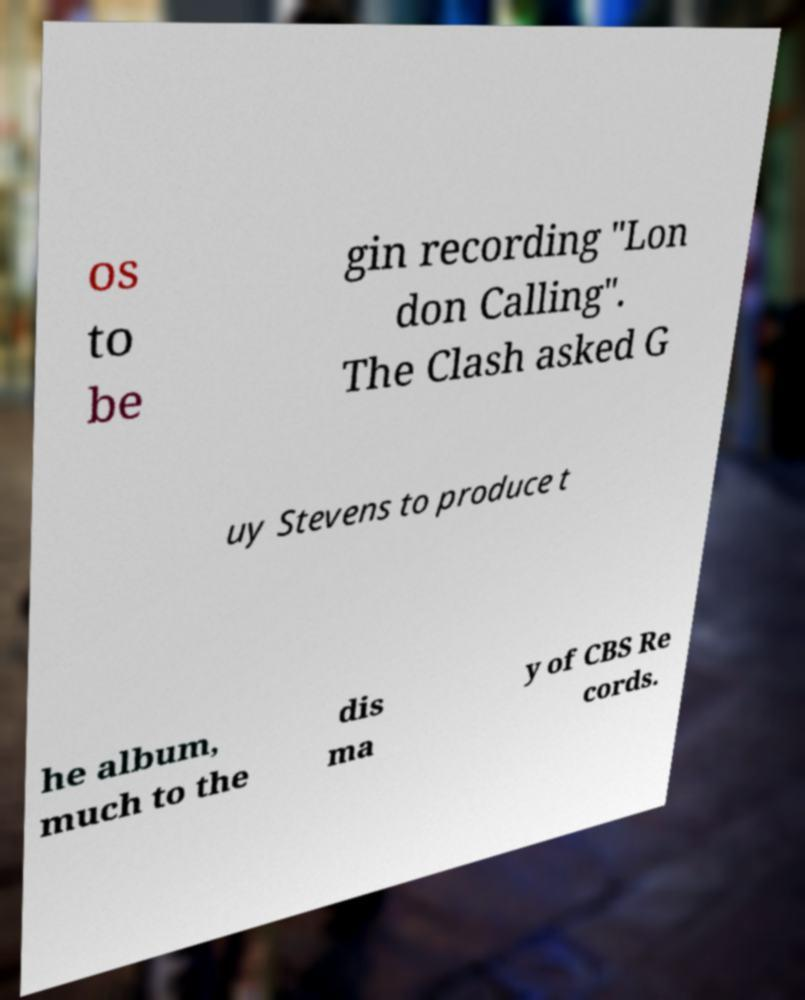Could you extract and type out the text from this image? os to be gin recording "Lon don Calling". The Clash asked G uy Stevens to produce t he album, much to the dis ma y of CBS Re cords. 